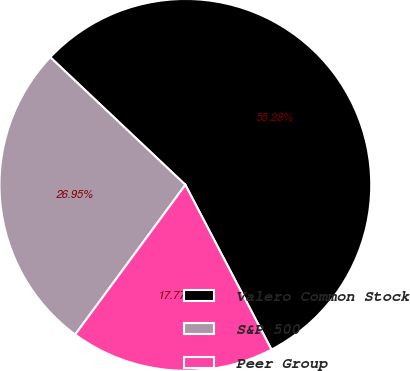Convert chart to OTSL. <chart><loc_0><loc_0><loc_500><loc_500><pie_chart><fcel>Valero Common Stock<fcel>S&P 500<fcel>Peer Group<nl><fcel>55.29%<fcel>26.95%<fcel>17.77%<nl></chart> 